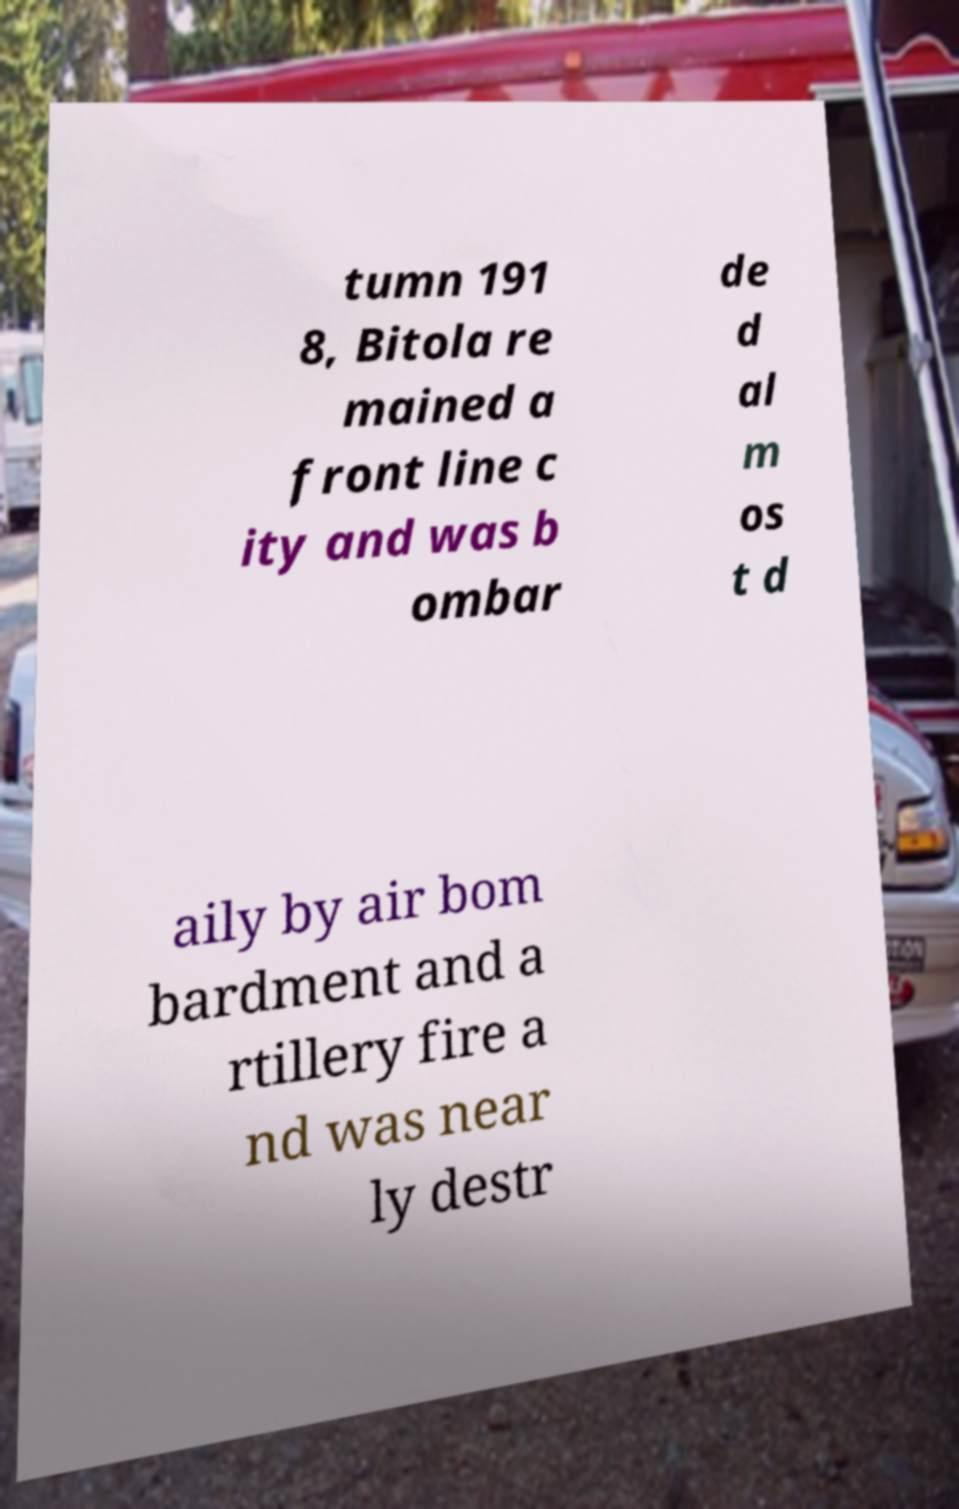What messages or text are displayed in this image? I need them in a readable, typed format. tumn 191 8, Bitola re mained a front line c ity and was b ombar de d al m os t d aily by air bom bardment and a rtillery fire a nd was near ly destr 